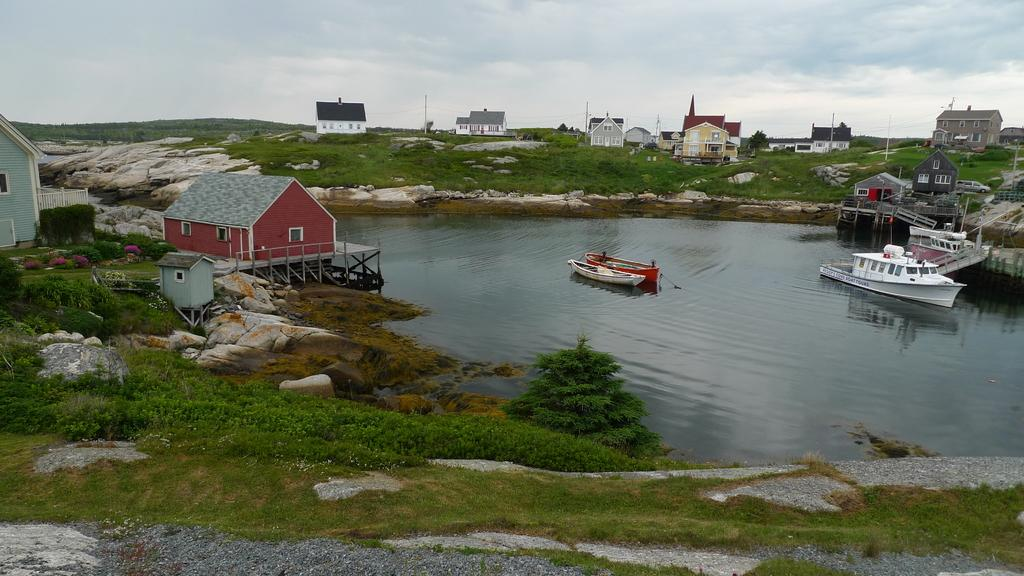What type of structures can be seen in the image? There are houses in the image. What is located on the water in the image? There are three boats on the lake. What type of vegetation is present in the image? There are plants, trees, and grass in the image. What type of ground surface is visible in the image? There are stones in the image. What part of the natural environment is visible in the image? The sky is visible in the image. How many dogs are playing with the boats in the image? There are no dogs present in the image. What is the relation between the houses and the boats in the image? The houses and boats are separate entities in the image, and no specific relation is depicted. 